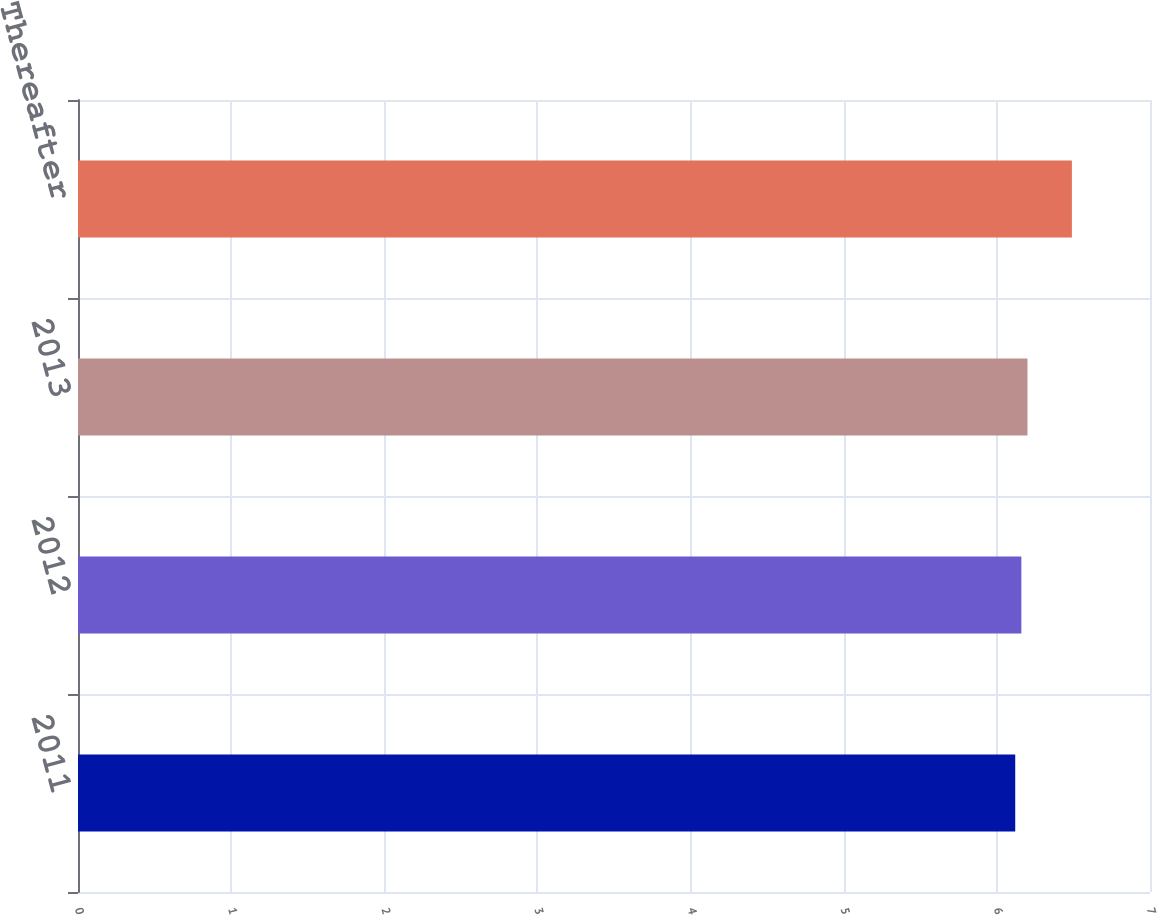Convert chart. <chart><loc_0><loc_0><loc_500><loc_500><bar_chart><fcel>2011<fcel>2012<fcel>2013<fcel>Thereafter<nl><fcel>6.12<fcel>6.16<fcel>6.2<fcel>6.49<nl></chart> 